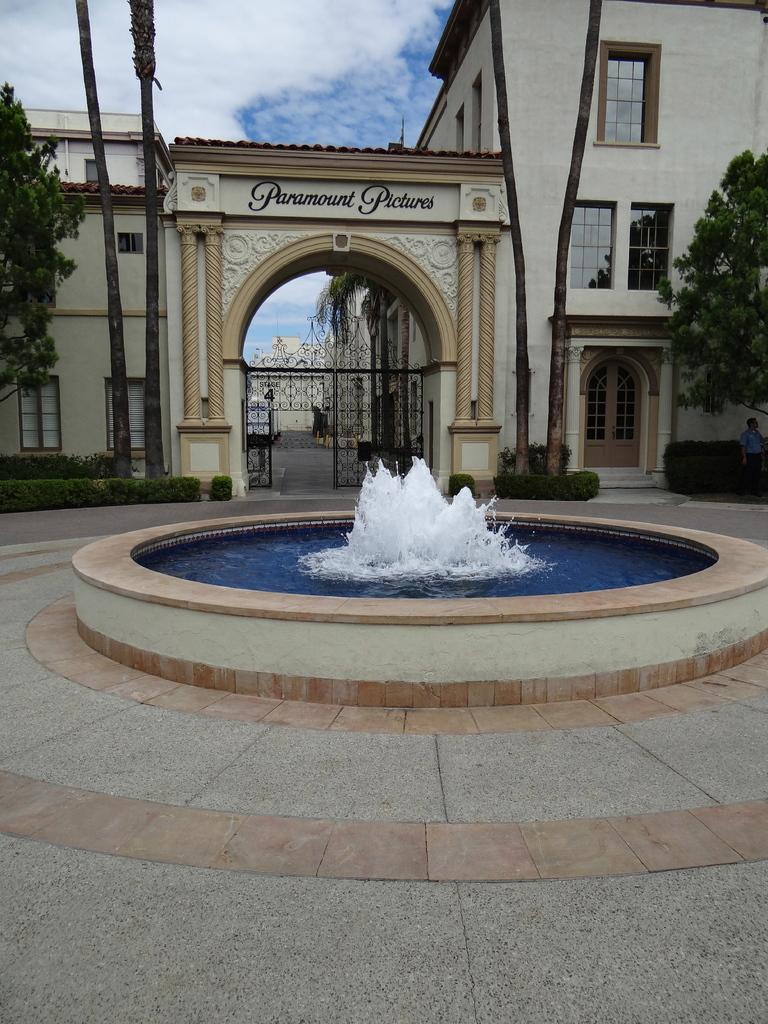Can you describe this image briefly? In this image we can see the building, gate, trees, shrubs and also the water fountain. We can also see a person on the right. We can see the path and also the sky with the clouds. 